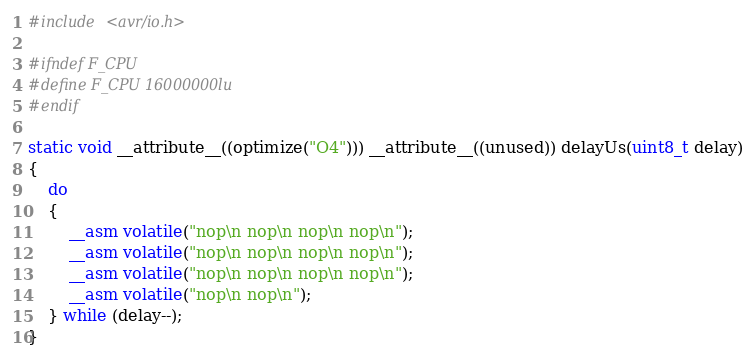<code> <loc_0><loc_0><loc_500><loc_500><_C_>#include <avr/io.h>

#ifndef F_CPU
#define F_CPU 16000000lu
#endif

static void __attribute__((optimize("O4"))) __attribute__((unused)) delayUs(uint8_t delay)
{
    do
    {
        __asm volatile("nop\n nop\n nop\n nop\n");
        __asm volatile("nop\n nop\n nop\n nop\n");
        __asm volatile("nop\n nop\n nop\n nop\n");
        __asm volatile("nop\n nop\n");
    } while (delay--);
}</code> 